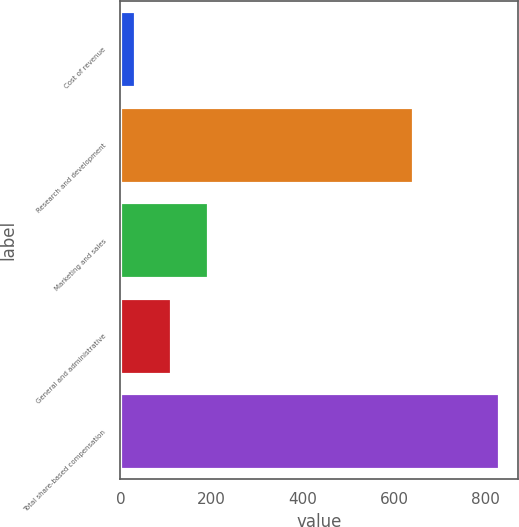<chart> <loc_0><loc_0><loc_500><loc_500><bar_chart><fcel>Cost of revenue<fcel>Research and development<fcel>Marketing and sales<fcel>General and administrative<fcel>Total share-based compensation<nl><fcel>32<fcel>641<fcel>191.8<fcel>111.9<fcel>831<nl></chart> 